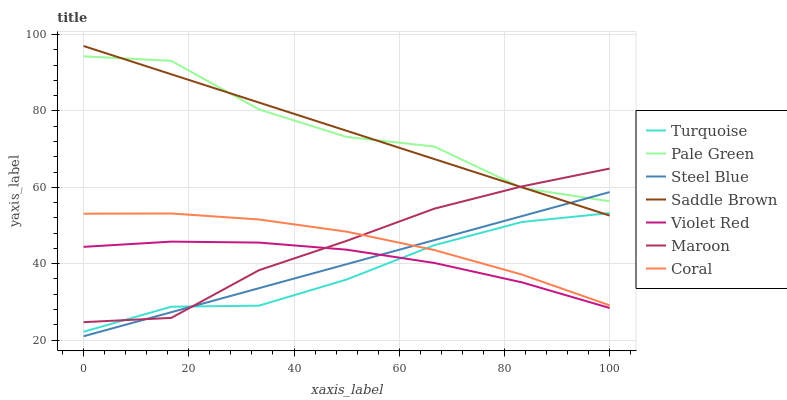Does Turquoise have the minimum area under the curve?
Answer yes or no. Yes. Does Pale Green have the maximum area under the curve?
Answer yes or no. Yes. Does Coral have the minimum area under the curve?
Answer yes or no. No. Does Coral have the maximum area under the curve?
Answer yes or no. No. Is Steel Blue the smoothest?
Answer yes or no. Yes. Is Pale Green the roughest?
Answer yes or no. Yes. Is Coral the smoothest?
Answer yes or no. No. Is Coral the roughest?
Answer yes or no. No. Does Steel Blue have the lowest value?
Answer yes or no. Yes. Does Coral have the lowest value?
Answer yes or no. No. Does Saddle Brown have the highest value?
Answer yes or no. Yes. Does Coral have the highest value?
Answer yes or no. No. Is Violet Red less than Pale Green?
Answer yes or no. Yes. Is Pale Green greater than Turquoise?
Answer yes or no. Yes. Does Steel Blue intersect Saddle Brown?
Answer yes or no. Yes. Is Steel Blue less than Saddle Brown?
Answer yes or no. No. Is Steel Blue greater than Saddle Brown?
Answer yes or no. No. Does Violet Red intersect Pale Green?
Answer yes or no. No. 